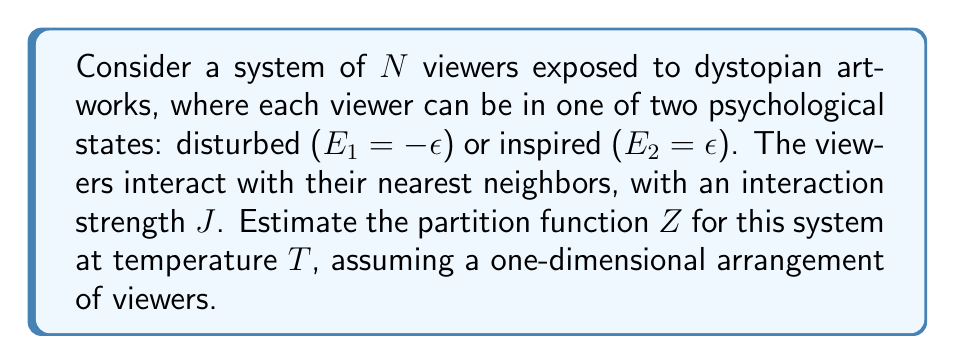Could you help me with this problem? To estimate the partition function for this system, we'll follow these steps:

1) The Hamiltonian for this system can be written as:

   $$H = -J\sum_{i=1}^N s_is_{i+1} - \epsilon\sum_{i=1}^N s_i$$

   where $s_i = \pm 1$ represents the state of the $i$-th viewer.

2) The partition function is given by:

   $$Z = \sum_{\{s_i\}} e^{-\beta H}$$

   where $\beta = \frac{1}{k_BT}$, $k_B$ is Boltzmann's constant, and the sum is over all possible configurations.

3) This system is analogous to the one-dimensional Ising model with an external field. The exact solution for the partition function in the thermodynamic limit ($N \to \infty$) is known:

   $$Z = \lambda_+^N + \lambda_-^N$$

   where $\lambda_\pm$ are the eigenvalues of the transfer matrix:

   $$\lambda_\pm = e^{\beta J} \cosh(\beta\epsilon) \pm \sqrt{e^{2\beta J} \sinh^2(\beta\epsilon) + e^{-2\beta J}}$$

4) For a finite system, we can approximate:

   $$Z \approx \lambda_+^N$$

   as $\lambda_+ > \lambda_-$ for all temperatures.

5) Taking the logarithm and expanding for high temperatures ($\beta J \ll 1$ and $\beta\epsilon \ll 1$):

   $$\ln Z \approx N \ln(\lambda_+) \approx N[\beta J + \ln(2) + \frac{1}{2}(\beta\epsilon)^2 + \frac{1}{2}(\beta J)^2]$$

This approximation gives us an estimate of the partition function for the system of interacting viewers exposed to dystopian artworks.
Answer: $Z \approx \exp[N(\beta J + \ln(2) + \frac{1}{2}(\beta\epsilon)^2 + \frac{1}{2}(\beta J)^2)]$ 